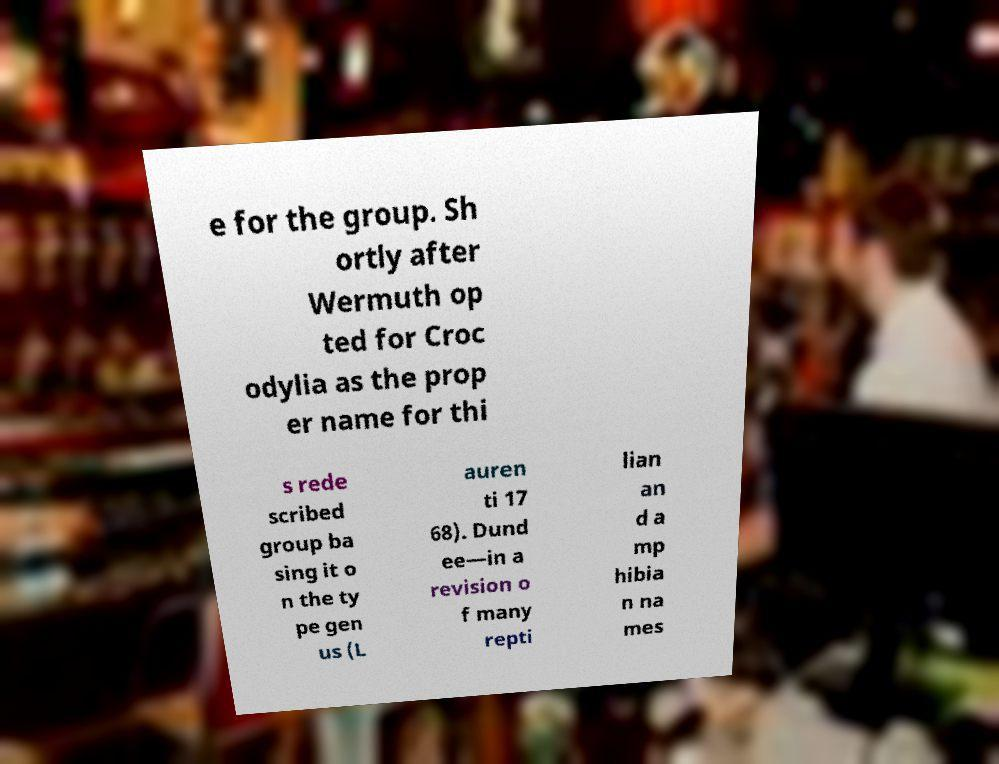Could you extract and type out the text from this image? e for the group. Sh ortly after Wermuth op ted for Croc odylia as the prop er name for thi s rede scribed group ba sing it o n the ty pe gen us (L auren ti 17 68). Dund ee—in a revision o f many repti lian an d a mp hibia n na mes 